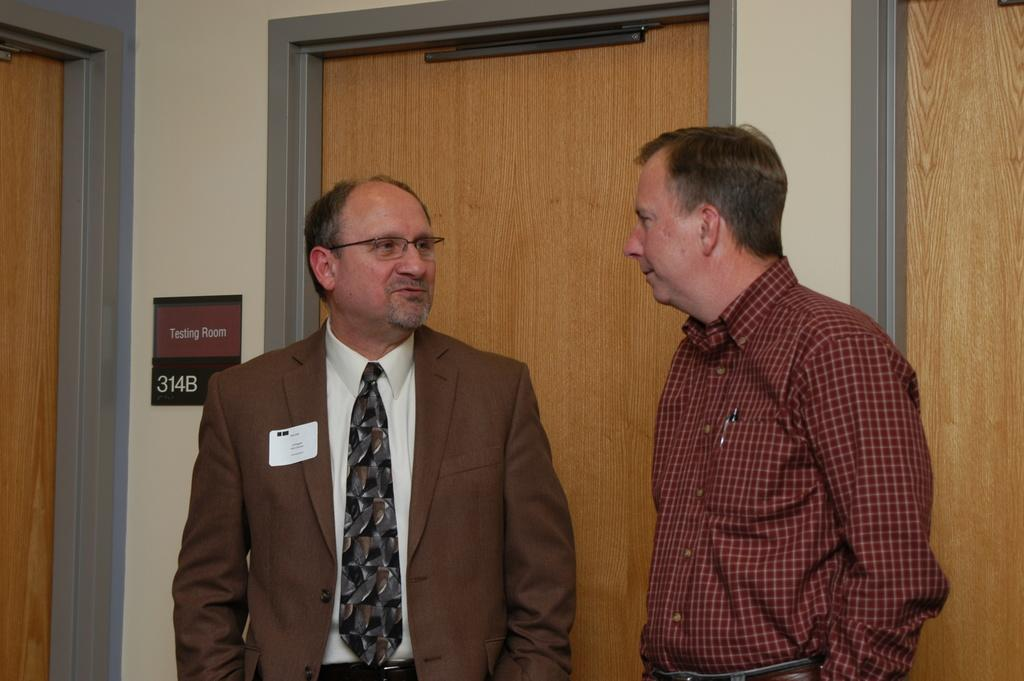How many people are in the image? There are two men in the image. Can you describe the attire of one of the men? One of the men is wearing a coat and tie. What can be seen in the background of the image? There are doors visible in the background of the image. What type of brick is being used to build the yard in the image? There is no yard or brick present in the image; it features two men and doors in the background. 